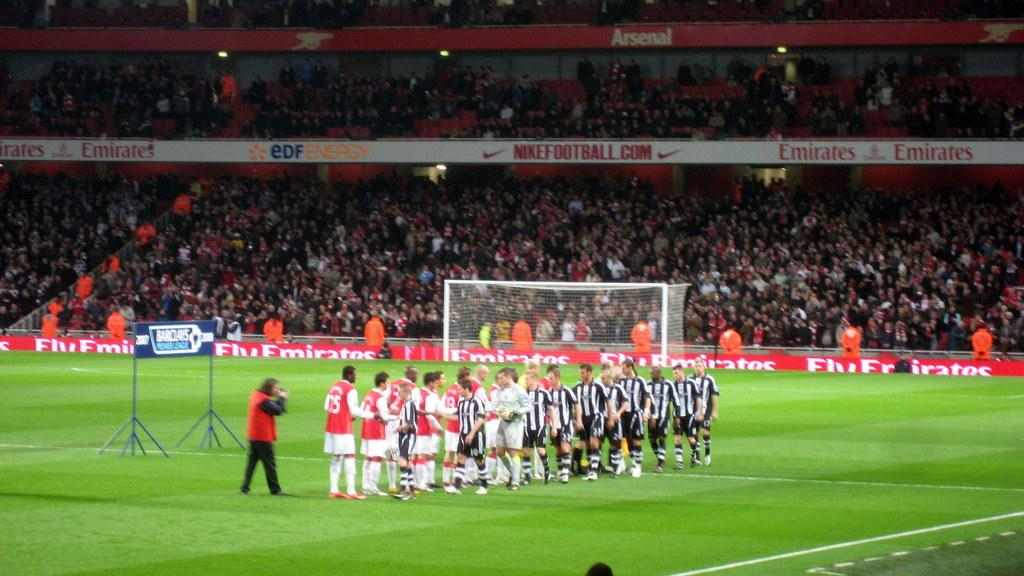What is happening in the image? There are players in the image, which suggests some form of game or sport is being played. What colors are the players wearing? The players are wearing black, white, and red color dresses. What is the main feature of the game or sport being played? There is a goal post in the image, which indicates that the sport might be soccer or hockey. What else can be seen in the image besides the players and goal post? There are boards and a group of people visible in the image. Can you see any patches on the players' dresses in the image? There is no mention of patches on the players' dresses in the provided facts, so we cannot determine their presence from the image. How many steps does the wheel take to reach the goal post in the image? There is no wheel present in the image, so this question cannot be answered. 